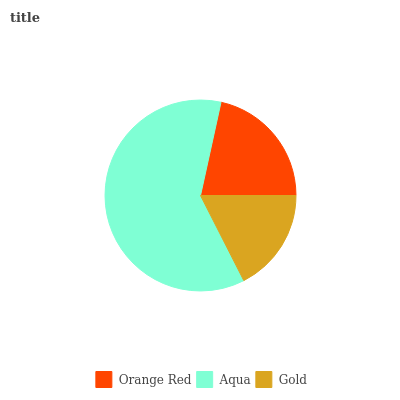Is Gold the minimum?
Answer yes or no. Yes. Is Aqua the maximum?
Answer yes or no. Yes. Is Aqua the minimum?
Answer yes or no. No. Is Gold the maximum?
Answer yes or no. No. Is Aqua greater than Gold?
Answer yes or no. Yes. Is Gold less than Aqua?
Answer yes or no. Yes. Is Gold greater than Aqua?
Answer yes or no. No. Is Aqua less than Gold?
Answer yes or no. No. Is Orange Red the high median?
Answer yes or no. Yes. Is Orange Red the low median?
Answer yes or no. Yes. Is Aqua the high median?
Answer yes or no. No. Is Aqua the low median?
Answer yes or no. No. 